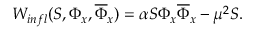<formula> <loc_0><loc_0><loc_500><loc_500>W _ { i n f l } ( S , \Phi _ { x } , \overline { \Phi } _ { x } ) = \alpha S \Phi _ { x } \overline { \Phi } _ { x } - \mu ^ { 2 } S .</formula> 